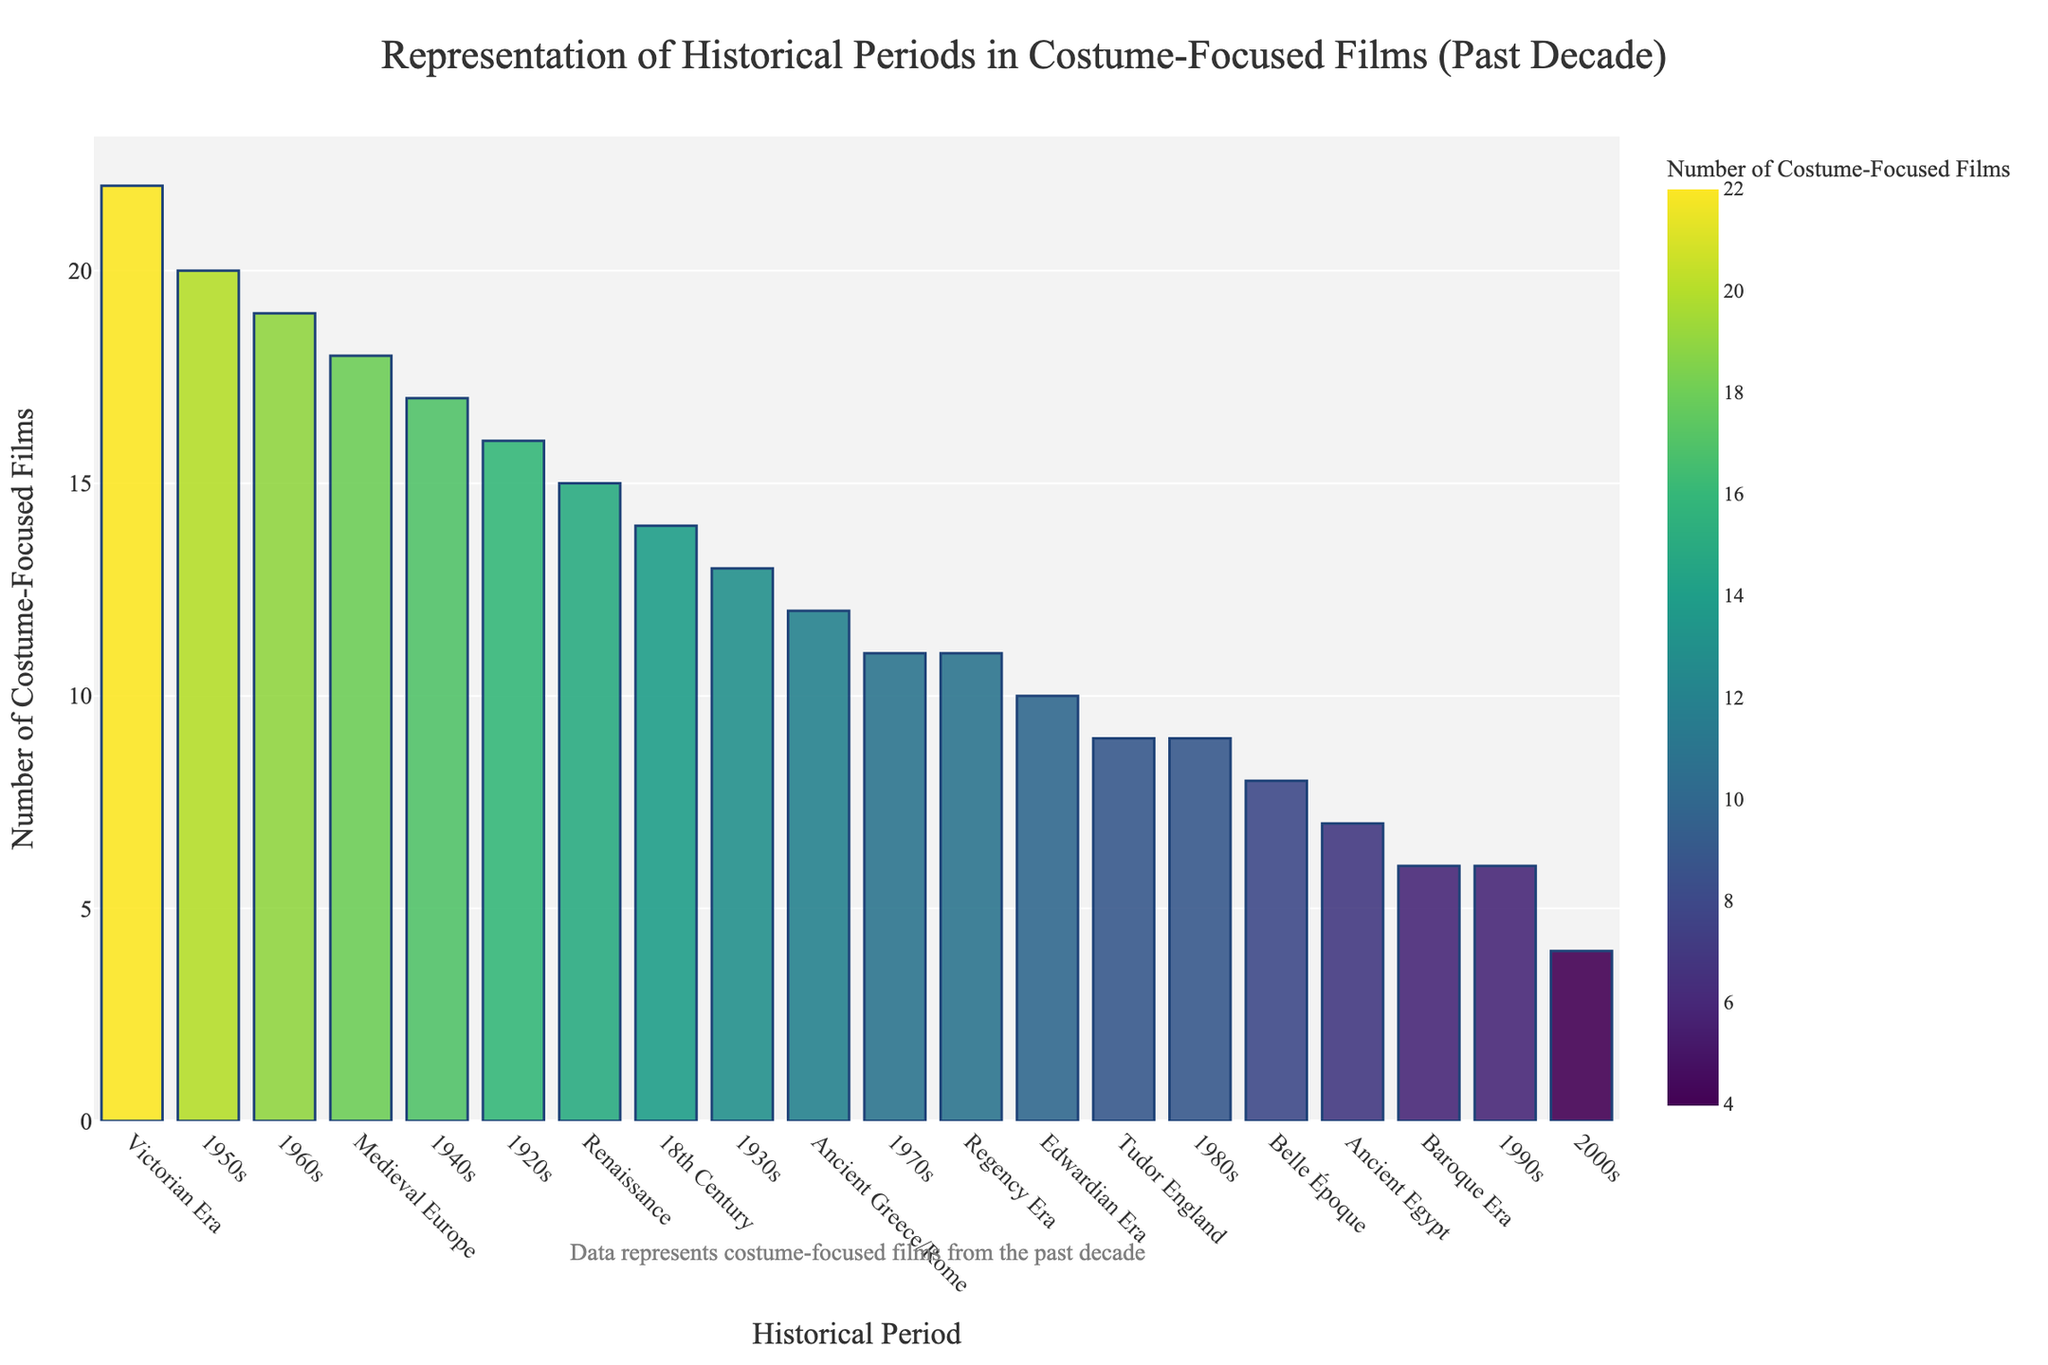Which historical period features the highest number of costume-focused films? Locate the bar with the greatest height on the chart, which represents the Victorian Era.
Answer: Victorian Era How many more costume-focused films represent the 1950s compared to the Regency Era? Note the height of the bars corresponding to the 1950s (20 films) and the Regency Era (11 films) and subtract the latter from the former. 20 - 11 = 9
Answer: 9 Which two historical periods combined have the same number of films as the 1960s? First, identify films for each period (1960s has 19). Then add numbers from other periods to match this sum. Adding 9 (Tudor England) and 10 (Edwardian Era) equals 19.
Answer: Tudor England and Edwardian Era What is the total number of costume-focused films representing the 20th century (1920s to 1990s)? Sum the number of films representing each decade within the 20th century: 16 (1920s) + 13 (1930s) + 17 (1940s) + 20 (1950s) + 19 (1960s) + 11 (1970s) + 9 (1980s) + 6 (1990s). The total is 111.
Answer: 111 Which historical period associated with ancient civilizations has the least number of costume-focused films? Compare the number of films for Ancient Egypt (7) and Ancient Greece/Rome (12), and identify the lesser number, which is for Ancient Egypt.
Answer: Ancient Egypt Is the number of films representing the Medieval Europe era greater than the number of films representing the Renaissance era? Compare the numbers of films between Medieval Europe (18) and Renaissance (15). Since 18 > 15, the answer is yes.
Answer: Yes What is the average number of costume-focused films included in the Victorian Era and the 1950s? First, find the sum of the films in these two periods, which are 22 (Victorian Era) and 20 (1950s). Calculate the average by (22 + 20) / 2 = 21.
Answer: 21 Which period between the Tudor England and Baroque Era has more films, and by how much? Compare Tudor England (9 films) with Baroque Era (6 films) and subtract the smaller number from the larger one. 9 - 6 = 3
Answer: Tudor England by 3 How many fewer films are there in the Baroque Era compared to the 18th Century? Note the number of films for the respective periods: Baroque Era (6) and 18th Century (14). Subtract 6 from 14 to find the difference. 14 - 6 = 8
Answer: 8 What percentage of the total films are represented by the Ancient Greece/Rome period? First, sum the total number of films represented by all periods. Then, divide the number of films represented by Ancient Greece/Rome (12) by this total and multiply by 100 to get the percentage. The total is 245; (12 / 245) * 100 ≈ 4.90%.
Answer: Approximately 4.90% 